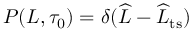<formula> <loc_0><loc_0><loc_500><loc_500>P ( L , \tau _ { 0 } ) = \delta ( \widehat { L } - \widehat { L } _ { t s } )</formula> 